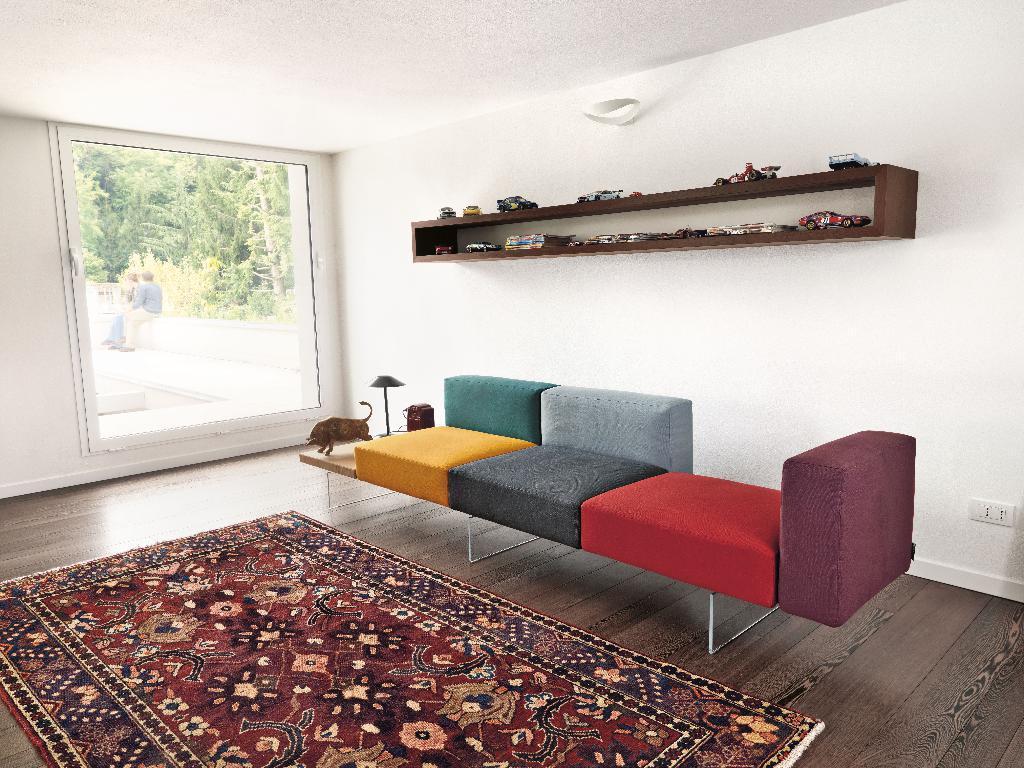Please provide a concise description of this image. Here in this we can see a sofa and a carpet on the floor and there is a window on the left side and outside that we can see trees and a couple of people sitting 